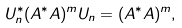Convert formula to latex. <formula><loc_0><loc_0><loc_500><loc_500>U _ { n } ^ { * } ( A ^ { * } A ) ^ { m } U _ { n } = ( A ^ { * } A ) ^ { m } ,</formula> 